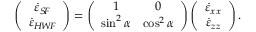<formula> <loc_0><loc_0><loc_500><loc_500>\left ( \begin{array} { c } { \dot { \varepsilon } _ { S \, F } } \\ { \dot { \varepsilon } _ { H \, W \, F } } \end{array} \right ) = \left ( \begin{array} { c c } { 1 } & { 0 } \\ { \sin ^ { 2 } \alpha } & { \cos ^ { 2 } \alpha } \end{array} \right ) \left ( \begin{array} { c } { \dot { \varepsilon } _ { x x } } \\ { \dot { \varepsilon } _ { z z } } \end{array} \right ) .</formula> 